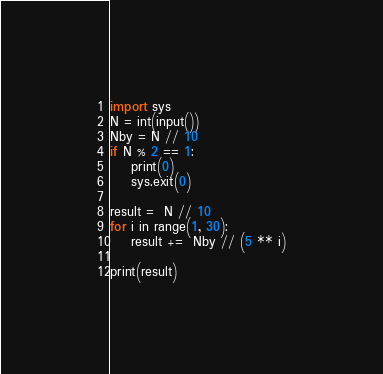<code> <loc_0><loc_0><loc_500><loc_500><_Python_>
import sys
N = int(input())
Nby = N // 10
if N % 2 == 1:
    print(0)
    sys.exit(0)

result =  N // 10
for i in range(1, 30):
    result +=  Nby // (5 ** i)

print(result)
</code> 